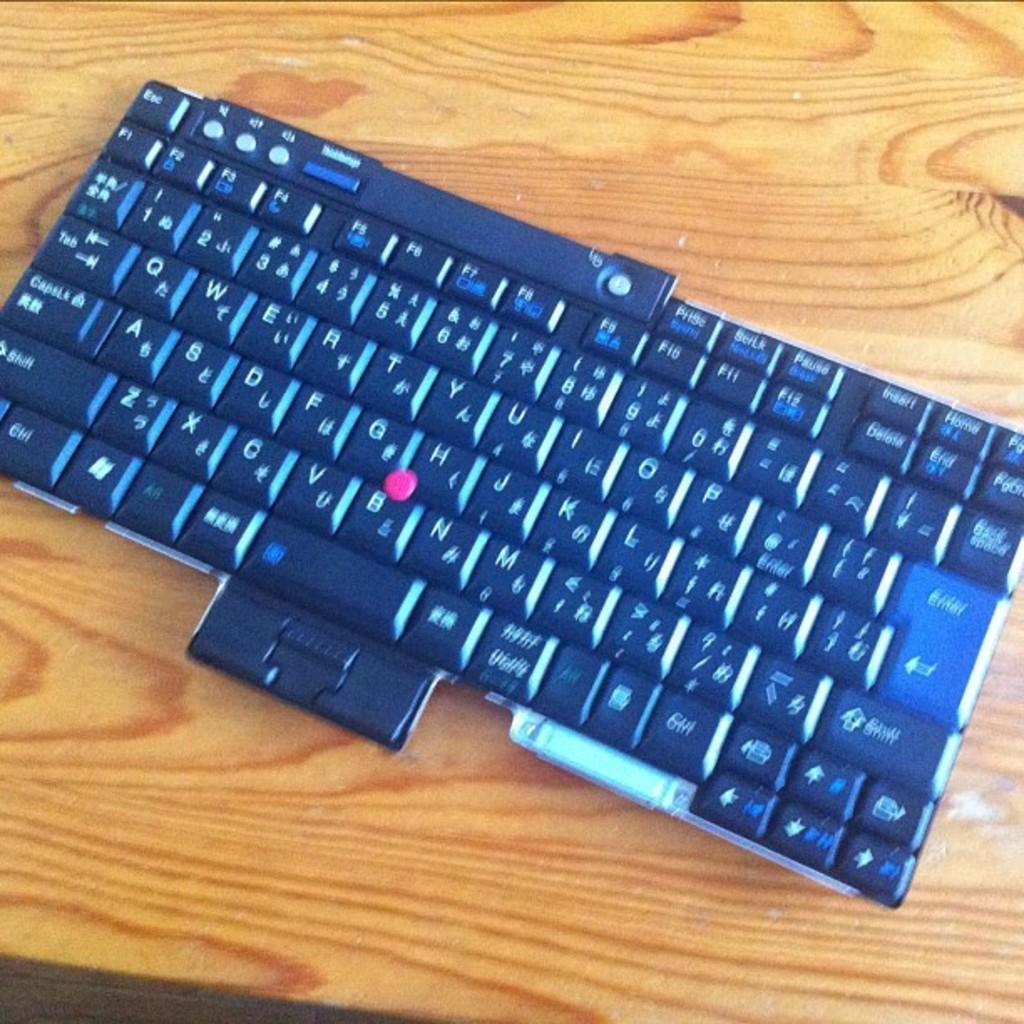Provide a one-sentence caption for the provided image. a keyboard with the letters a-z with a red dot between the letters g, h and b. 